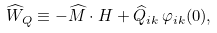Convert formula to latex. <formula><loc_0><loc_0><loc_500><loc_500>\widehat { W } _ { Q } \equiv - \widehat { M } \cdot H + \widehat { Q } _ { i k } \, \varphi _ { i k } ( 0 ) ,</formula> 